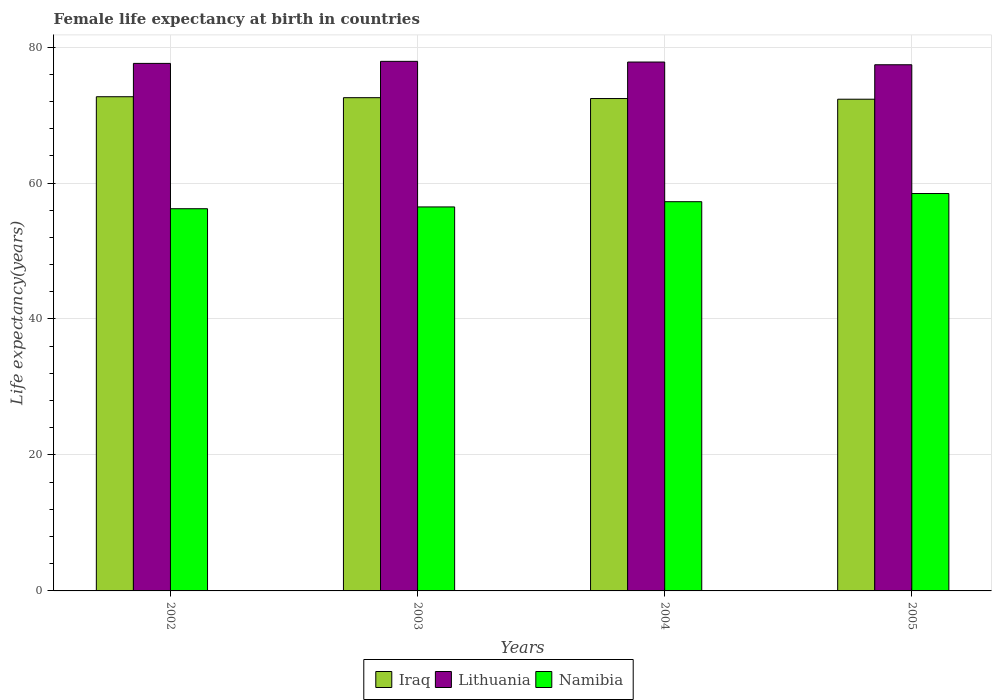Are the number of bars on each tick of the X-axis equal?
Provide a succinct answer. Yes. How many bars are there on the 1st tick from the left?
Give a very brief answer. 3. What is the female life expectancy at birth in Iraq in 2002?
Offer a terse response. 72.7. Across all years, what is the maximum female life expectancy at birth in Iraq?
Keep it short and to the point. 72.7. Across all years, what is the minimum female life expectancy at birth in Namibia?
Offer a very short reply. 56.22. In which year was the female life expectancy at birth in Iraq maximum?
Your answer should be very brief. 2002. In which year was the female life expectancy at birth in Iraq minimum?
Your answer should be compact. 2005. What is the total female life expectancy at birth in Iraq in the graph?
Your answer should be compact. 290.01. What is the difference between the female life expectancy at birth in Lithuania in 2004 and that in 2005?
Your response must be concise. 0.4. What is the difference between the female life expectancy at birth in Lithuania in 2005 and the female life expectancy at birth in Namibia in 2002?
Make the answer very short. 21.18. What is the average female life expectancy at birth in Lithuania per year?
Give a very brief answer. 77.68. In the year 2003, what is the difference between the female life expectancy at birth in Iraq and female life expectancy at birth in Lithuania?
Offer a very short reply. -5.34. In how many years, is the female life expectancy at birth in Lithuania greater than 28 years?
Make the answer very short. 4. What is the ratio of the female life expectancy at birth in Lithuania in 2002 to that in 2005?
Offer a terse response. 1. Is the female life expectancy at birth in Lithuania in 2002 less than that in 2003?
Your response must be concise. Yes. What is the difference between the highest and the second highest female life expectancy at birth in Namibia?
Provide a succinct answer. 1.2. What is the difference between the highest and the lowest female life expectancy at birth in Lithuania?
Keep it short and to the point. 0.5. In how many years, is the female life expectancy at birth in Lithuania greater than the average female life expectancy at birth in Lithuania taken over all years?
Ensure brevity in your answer.  2. What does the 3rd bar from the left in 2003 represents?
Provide a short and direct response. Namibia. What does the 3rd bar from the right in 2003 represents?
Give a very brief answer. Iraq. Is it the case that in every year, the sum of the female life expectancy at birth in Iraq and female life expectancy at birth in Lithuania is greater than the female life expectancy at birth in Namibia?
Keep it short and to the point. Yes. Are all the bars in the graph horizontal?
Offer a very short reply. No. What is the difference between two consecutive major ticks on the Y-axis?
Offer a very short reply. 20. Are the values on the major ticks of Y-axis written in scientific E-notation?
Keep it short and to the point. No. Does the graph contain any zero values?
Your answer should be very brief. No. Does the graph contain grids?
Make the answer very short. Yes. What is the title of the graph?
Give a very brief answer. Female life expectancy at birth in countries. What is the label or title of the Y-axis?
Keep it short and to the point. Life expectancy(years). What is the Life expectancy(years) in Iraq in 2002?
Your response must be concise. 72.7. What is the Life expectancy(years) in Lithuania in 2002?
Offer a terse response. 77.6. What is the Life expectancy(years) in Namibia in 2002?
Offer a very short reply. 56.22. What is the Life expectancy(years) of Iraq in 2003?
Ensure brevity in your answer.  72.56. What is the Life expectancy(years) of Lithuania in 2003?
Keep it short and to the point. 77.9. What is the Life expectancy(years) of Namibia in 2003?
Keep it short and to the point. 56.48. What is the Life expectancy(years) in Iraq in 2004?
Give a very brief answer. 72.43. What is the Life expectancy(years) of Lithuania in 2004?
Provide a short and direct response. 77.8. What is the Life expectancy(years) in Namibia in 2004?
Your answer should be compact. 57.26. What is the Life expectancy(years) of Iraq in 2005?
Your answer should be very brief. 72.33. What is the Life expectancy(years) in Lithuania in 2005?
Your answer should be very brief. 77.4. What is the Life expectancy(years) in Namibia in 2005?
Your answer should be compact. 58.46. Across all years, what is the maximum Life expectancy(years) in Iraq?
Your answer should be compact. 72.7. Across all years, what is the maximum Life expectancy(years) of Lithuania?
Provide a short and direct response. 77.9. Across all years, what is the maximum Life expectancy(years) in Namibia?
Keep it short and to the point. 58.46. Across all years, what is the minimum Life expectancy(years) in Iraq?
Provide a succinct answer. 72.33. Across all years, what is the minimum Life expectancy(years) in Lithuania?
Provide a succinct answer. 77.4. Across all years, what is the minimum Life expectancy(years) in Namibia?
Offer a very short reply. 56.22. What is the total Life expectancy(years) of Iraq in the graph?
Ensure brevity in your answer.  290.01. What is the total Life expectancy(years) in Lithuania in the graph?
Your answer should be very brief. 310.7. What is the total Life expectancy(years) of Namibia in the graph?
Your answer should be compact. 228.42. What is the difference between the Life expectancy(years) of Iraq in 2002 and that in 2003?
Offer a terse response. 0.14. What is the difference between the Life expectancy(years) of Namibia in 2002 and that in 2003?
Provide a succinct answer. -0.26. What is the difference between the Life expectancy(years) of Iraq in 2002 and that in 2004?
Ensure brevity in your answer.  0.27. What is the difference between the Life expectancy(years) of Namibia in 2002 and that in 2004?
Keep it short and to the point. -1.03. What is the difference between the Life expectancy(years) of Iraq in 2002 and that in 2005?
Provide a succinct answer. 0.37. What is the difference between the Life expectancy(years) in Lithuania in 2002 and that in 2005?
Your response must be concise. 0.2. What is the difference between the Life expectancy(years) of Namibia in 2002 and that in 2005?
Make the answer very short. -2.24. What is the difference between the Life expectancy(years) in Iraq in 2003 and that in 2004?
Your answer should be compact. 0.13. What is the difference between the Life expectancy(years) in Lithuania in 2003 and that in 2004?
Offer a terse response. 0.1. What is the difference between the Life expectancy(years) in Namibia in 2003 and that in 2004?
Offer a terse response. -0.77. What is the difference between the Life expectancy(years) of Iraq in 2003 and that in 2005?
Your answer should be compact. 0.23. What is the difference between the Life expectancy(years) of Namibia in 2003 and that in 2005?
Keep it short and to the point. -1.97. What is the difference between the Life expectancy(years) in Iraq in 2004 and that in 2005?
Offer a very short reply. 0.1. What is the difference between the Life expectancy(years) in Lithuania in 2004 and that in 2005?
Your response must be concise. 0.4. What is the difference between the Life expectancy(years) of Namibia in 2004 and that in 2005?
Provide a succinct answer. -1.2. What is the difference between the Life expectancy(years) in Iraq in 2002 and the Life expectancy(years) in Lithuania in 2003?
Give a very brief answer. -5.2. What is the difference between the Life expectancy(years) of Iraq in 2002 and the Life expectancy(years) of Namibia in 2003?
Your answer should be very brief. 16.21. What is the difference between the Life expectancy(years) in Lithuania in 2002 and the Life expectancy(years) in Namibia in 2003?
Your answer should be very brief. 21.11. What is the difference between the Life expectancy(years) in Iraq in 2002 and the Life expectancy(years) in Lithuania in 2004?
Your answer should be compact. -5.1. What is the difference between the Life expectancy(years) in Iraq in 2002 and the Life expectancy(years) in Namibia in 2004?
Provide a succinct answer. 15.44. What is the difference between the Life expectancy(years) in Lithuania in 2002 and the Life expectancy(years) in Namibia in 2004?
Make the answer very short. 20.34. What is the difference between the Life expectancy(years) in Iraq in 2002 and the Life expectancy(years) in Lithuania in 2005?
Your answer should be very brief. -4.7. What is the difference between the Life expectancy(years) of Iraq in 2002 and the Life expectancy(years) of Namibia in 2005?
Provide a succinct answer. 14.24. What is the difference between the Life expectancy(years) of Lithuania in 2002 and the Life expectancy(years) of Namibia in 2005?
Keep it short and to the point. 19.14. What is the difference between the Life expectancy(years) in Iraq in 2003 and the Life expectancy(years) in Lithuania in 2004?
Your response must be concise. -5.24. What is the difference between the Life expectancy(years) in Iraq in 2003 and the Life expectancy(years) in Namibia in 2004?
Ensure brevity in your answer.  15.3. What is the difference between the Life expectancy(years) in Lithuania in 2003 and the Life expectancy(years) in Namibia in 2004?
Ensure brevity in your answer.  20.64. What is the difference between the Life expectancy(years) in Iraq in 2003 and the Life expectancy(years) in Lithuania in 2005?
Your response must be concise. -4.84. What is the difference between the Life expectancy(years) of Iraq in 2003 and the Life expectancy(years) of Namibia in 2005?
Your answer should be compact. 14.1. What is the difference between the Life expectancy(years) in Lithuania in 2003 and the Life expectancy(years) in Namibia in 2005?
Offer a terse response. 19.44. What is the difference between the Life expectancy(years) in Iraq in 2004 and the Life expectancy(years) in Lithuania in 2005?
Offer a terse response. -4.97. What is the difference between the Life expectancy(years) in Iraq in 2004 and the Life expectancy(years) in Namibia in 2005?
Your answer should be compact. 13.97. What is the difference between the Life expectancy(years) of Lithuania in 2004 and the Life expectancy(years) of Namibia in 2005?
Keep it short and to the point. 19.34. What is the average Life expectancy(years) of Iraq per year?
Provide a short and direct response. 72.5. What is the average Life expectancy(years) of Lithuania per year?
Ensure brevity in your answer.  77.67. What is the average Life expectancy(years) in Namibia per year?
Make the answer very short. 57.11. In the year 2002, what is the difference between the Life expectancy(years) of Iraq and Life expectancy(years) of Lithuania?
Offer a very short reply. -4.9. In the year 2002, what is the difference between the Life expectancy(years) in Iraq and Life expectancy(years) in Namibia?
Give a very brief answer. 16.48. In the year 2002, what is the difference between the Life expectancy(years) in Lithuania and Life expectancy(years) in Namibia?
Make the answer very short. 21.38. In the year 2003, what is the difference between the Life expectancy(years) in Iraq and Life expectancy(years) in Lithuania?
Give a very brief answer. -5.34. In the year 2003, what is the difference between the Life expectancy(years) of Iraq and Life expectancy(years) of Namibia?
Provide a succinct answer. 16.07. In the year 2003, what is the difference between the Life expectancy(years) in Lithuania and Life expectancy(years) in Namibia?
Give a very brief answer. 21.41. In the year 2004, what is the difference between the Life expectancy(years) in Iraq and Life expectancy(years) in Lithuania?
Offer a terse response. -5.37. In the year 2004, what is the difference between the Life expectancy(years) of Iraq and Life expectancy(years) of Namibia?
Your response must be concise. 15.17. In the year 2004, what is the difference between the Life expectancy(years) of Lithuania and Life expectancy(years) of Namibia?
Provide a short and direct response. 20.54. In the year 2005, what is the difference between the Life expectancy(years) in Iraq and Life expectancy(years) in Lithuania?
Make the answer very short. -5.07. In the year 2005, what is the difference between the Life expectancy(years) of Iraq and Life expectancy(years) of Namibia?
Offer a very short reply. 13.87. In the year 2005, what is the difference between the Life expectancy(years) in Lithuania and Life expectancy(years) in Namibia?
Your response must be concise. 18.94. What is the ratio of the Life expectancy(years) of Lithuania in 2002 to that in 2003?
Offer a terse response. 1. What is the ratio of the Life expectancy(years) of Namibia in 2002 to that in 2004?
Ensure brevity in your answer.  0.98. What is the ratio of the Life expectancy(years) of Iraq in 2002 to that in 2005?
Ensure brevity in your answer.  1.01. What is the ratio of the Life expectancy(years) in Lithuania in 2002 to that in 2005?
Your answer should be very brief. 1. What is the ratio of the Life expectancy(years) of Namibia in 2002 to that in 2005?
Your answer should be compact. 0.96. What is the ratio of the Life expectancy(years) in Iraq in 2003 to that in 2004?
Provide a short and direct response. 1. What is the ratio of the Life expectancy(years) in Namibia in 2003 to that in 2004?
Provide a short and direct response. 0.99. What is the ratio of the Life expectancy(years) in Lithuania in 2003 to that in 2005?
Give a very brief answer. 1.01. What is the ratio of the Life expectancy(years) of Namibia in 2003 to that in 2005?
Ensure brevity in your answer.  0.97. What is the ratio of the Life expectancy(years) of Lithuania in 2004 to that in 2005?
Keep it short and to the point. 1.01. What is the ratio of the Life expectancy(years) of Namibia in 2004 to that in 2005?
Give a very brief answer. 0.98. What is the difference between the highest and the second highest Life expectancy(years) in Iraq?
Your answer should be very brief. 0.14. What is the difference between the highest and the second highest Life expectancy(years) in Namibia?
Offer a terse response. 1.2. What is the difference between the highest and the lowest Life expectancy(years) in Iraq?
Your answer should be compact. 0.37. What is the difference between the highest and the lowest Life expectancy(years) of Lithuania?
Offer a very short reply. 0.5. What is the difference between the highest and the lowest Life expectancy(years) of Namibia?
Offer a terse response. 2.24. 